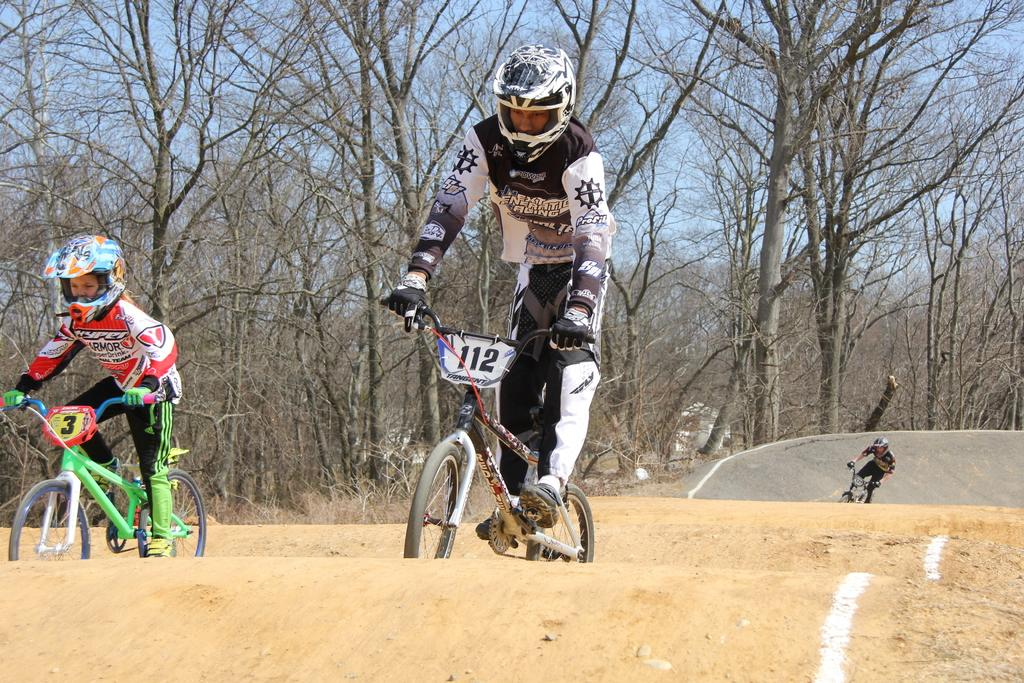How many people are in the image? There are three persons in the image. What are the persons doing in the image? The persons are riding bicycles. What safety precaution are the persons taking while riding bicycles? The persons are wearing helmets. What can be seen in the background of the image? There are trees in the background of the image. What is visible at the top of the image? The sky is visible at the top of the image. What type of button can be seen on the chicken's wing in the image? There is no chicken or button present in the image. How many nails are visible on the bicycle in the image? The image does not show any nails on the bicycles; it only shows the persons riding them. 